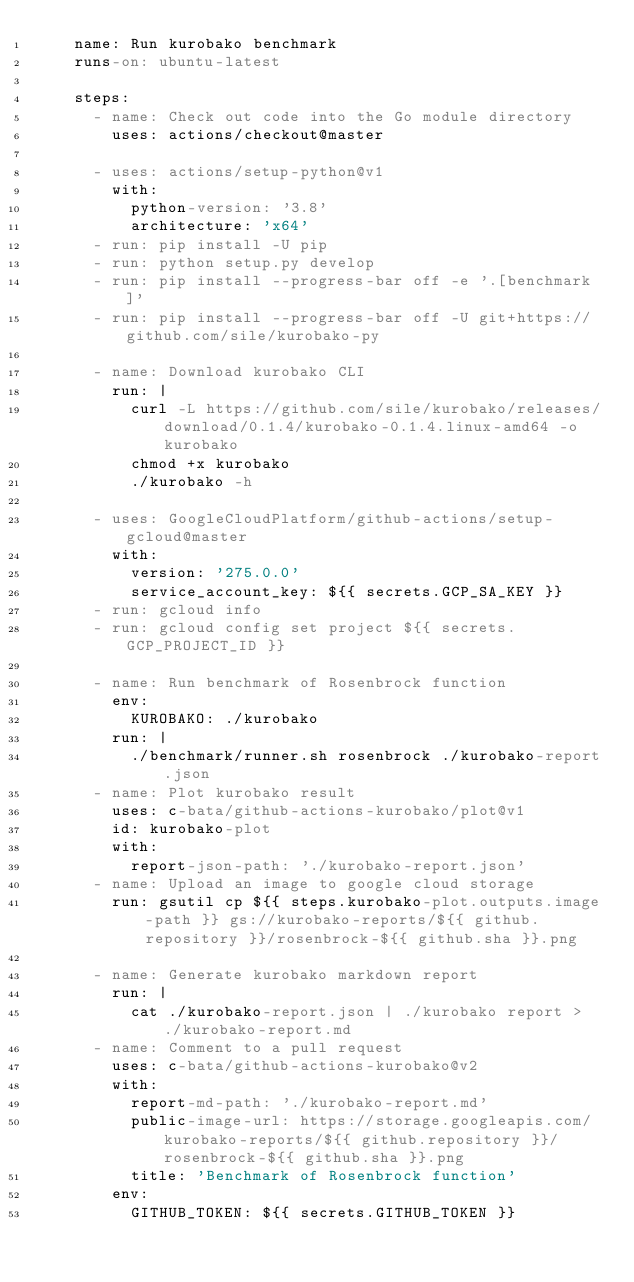<code> <loc_0><loc_0><loc_500><loc_500><_YAML_>    name: Run kurobako benchmark
    runs-on: ubuntu-latest

    steps:
      - name: Check out code into the Go module directory
        uses: actions/checkout@master

      - uses: actions/setup-python@v1
        with:
          python-version: '3.8'
          architecture: 'x64'
      - run: pip install -U pip
      - run: python setup.py develop
      - run: pip install --progress-bar off -e '.[benchmark]'
      - run: pip install --progress-bar off -U git+https://github.com/sile/kurobako-py

      - name: Download kurobako CLI
        run: |
          curl -L https://github.com/sile/kurobako/releases/download/0.1.4/kurobako-0.1.4.linux-amd64 -o kurobako
          chmod +x kurobako
          ./kurobako -h

      - uses: GoogleCloudPlatform/github-actions/setup-gcloud@master
        with:
          version: '275.0.0'
          service_account_key: ${{ secrets.GCP_SA_KEY }}
      - run: gcloud info
      - run: gcloud config set project ${{ secrets.GCP_PROJECT_ID }}

      - name: Run benchmark of Rosenbrock function
        env:
          KUROBAKO: ./kurobako
        run: |
          ./benchmark/runner.sh rosenbrock ./kurobako-report.json
      - name: Plot kurobako result
        uses: c-bata/github-actions-kurobako/plot@v1
        id: kurobako-plot
        with:
          report-json-path: './kurobako-report.json'
      - name: Upload an image to google cloud storage
        run: gsutil cp ${{ steps.kurobako-plot.outputs.image-path }} gs://kurobako-reports/${{ github.repository }}/rosenbrock-${{ github.sha }}.png

      - name: Generate kurobako markdown report
        run: |
          cat ./kurobako-report.json | ./kurobako report > ./kurobako-report.md
      - name: Comment to a pull request
        uses: c-bata/github-actions-kurobako@v2
        with:
          report-md-path: './kurobako-report.md'
          public-image-url: https://storage.googleapis.com/kurobako-reports/${{ github.repository }}/rosenbrock-${{ github.sha }}.png
          title: 'Benchmark of Rosenbrock function'
        env:
          GITHUB_TOKEN: ${{ secrets.GITHUB_TOKEN }}
</code> 